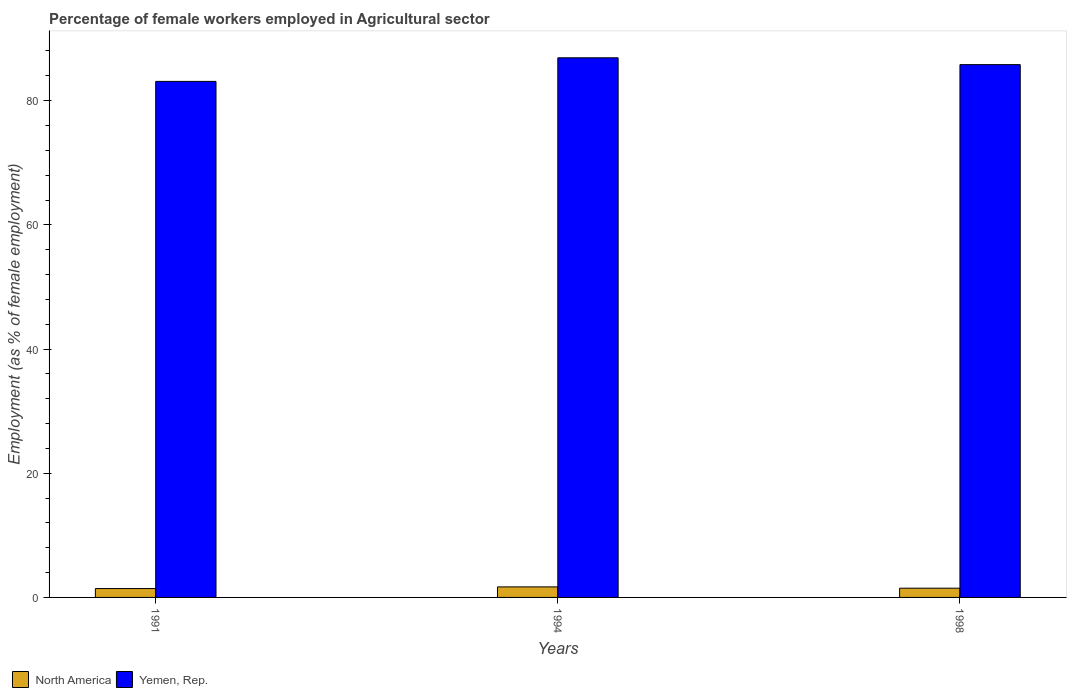How many different coloured bars are there?
Give a very brief answer. 2. Are the number of bars on each tick of the X-axis equal?
Your answer should be very brief. Yes. How many bars are there on the 2nd tick from the right?
Offer a terse response. 2. In how many cases, is the number of bars for a given year not equal to the number of legend labels?
Make the answer very short. 0. What is the percentage of females employed in Agricultural sector in North America in 1998?
Your answer should be very brief. 1.49. Across all years, what is the maximum percentage of females employed in Agricultural sector in Yemen, Rep.?
Offer a very short reply. 86.9. Across all years, what is the minimum percentage of females employed in Agricultural sector in Yemen, Rep.?
Offer a very short reply. 83.1. What is the total percentage of females employed in Agricultural sector in North America in the graph?
Give a very brief answer. 4.61. What is the difference between the percentage of females employed in Agricultural sector in Yemen, Rep. in 1991 and that in 1998?
Provide a succinct answer. -2.7. What is the difference between the percentage of females employed in Agricultural sector in North America in 1991 and the percentage of females employed in Agricultural sector in Yemen, Rep. in 1994?
Your answer should be very brief. -85.47. What is the average percentage of females employed in Agricultural sector in Yemen, Rep. per year?
Offer a terse response. 85.27. In the year 1991, what is the difference between the percentage of females employed in Agricultural sector in North America and percentage of females employed in Agricultural sector in Yemen, Rep.?
Provide a succinct answer. -81.67. What is the ratio of the percentage of females employed in Agricultural sector in North America in 1991 to that in 1994?
Keep it short and to the point. 0.84. Is the percentage of females employed in Agricultural sector in North America in 1991 less than that in 1994?
Your answer should be very brief. Yes. What is the difference between the highest and the second highest percentage of females employed in Agricultural sector in Yemen, Rep.?
Offer a very short reply. 1.1. What is the difference between the highest and the lowest percentage of females employed in Agricultural sector in North America?
Ensure brevity in your answer.  0.27. In how many years, is the percentage of females employed in Agricultural sector in North America greater than the average percentage of females employed in Agricultural sector in North America taken over all years?
Ensure brevity in your answer.  1. What does the 2nd bar from the left in 1991 represents?
Provide a succinct answer. Yemen, Rep. What does the 1st bar from the right in 1991 represents?
Give a very brief answer. Yemen, Rep. How many bars are there?
Your response must be concise. 6. Are all the bars in the graph horizontal?
Provide a short and direct response. No. How many years are there in the graph?
Give a very brief answer. 3. What is the difference between two consecutive major ticks on the Y-axis?
Offer a terse response. 20. Does the graph contain grids?
Make the answer very short. No. Where does the legend appear in the graph?
Your response must be concise. Bottom left. What is the title of the graph?
Ensure brevity in your answer.  Percentage of female workers employed in Agricultural sector. What is the label or title of the X-axis?
Keep it short and to the point. Years. What is the label or title of the Y-axis?
Offer a terse response. Employment (as % of female employment). What is the Employment (as % of female employment) in North America in 1991?
Keep it short and to the point. 1.43. What is the Employment (as % of female employment) in Yemen, Rep. in 1991?
Your response must be concise. 83.1. What is the Employment (as % of female employment) of North America in 1994?
Your answer should be very brief. 1.7. What is the Employment (as % of female employment) in Yemen, Rep. in 1994?
Provide a succinct answer. 86.9. What is the Employment (as % of female employment) of North America in 1998?
Offer a very short reply. 1.49. What is the Employment (as % of female employment) in Yemen, Rep. in 1998?
Give a very brief answer. 85.8. Across all years, what is the maximum Employment (as % of female employment) in North America?
Your response must be concise. 1.7. Across all years, what is the maximum Employment (as % of female employment) of Yemen, Rep.?
Your answer should be compact. 86.9. Across all years, what is the minimum Employment (as % of female employment) of North America?
Provide a succinct answer. 1.43. Across all years, what is the minimum Employment (as % of female employment) of Yemen, Rep.?
Make the answer very short. 83.1. What is the total Employment (as % of female employment) in North America in the graph?
Provide a short and direct response. 4.61. What is the total Employment (as % of female employment) of Yemen, Rep. in the graph?
Make the answer very short. 255.8. What is the difference between the Employment (as % of female employment) of North America in 1991 and that in 1994?
Your answer should be compact. -0.27. What is the difference between the Employment (as % of female employment) of North America in 1991 and that in 1998?
Provide a succinct answer. -0.06. What is the difference between the Employment (as % of female employment) of North America in 1994 and that in 1998?
Your answer should be compact. 0.21. What is the difference between the Employment (as % of female employment) in Yemen, Rep. in 1994 and that in 1998?
Offer a terse response. 1.1. What is the difference between the Employment (as % of female employment) of North America in 1991 and the Employment (as % of female employment) of Yemen, Rep. in 1994?
Ensure brevity in your answer.  -85.47. What is the difference between the Employment (as % of female employment) in North America in 1991 and the Employment (as % of female employment) in Yemen, Rep. in 1998?
Your response must be concise. -84.37. What is the difference between the Employment (as % of female employment) in North America in 1994 and the Employment (as % of female employment) in Yemen, Rep. in 1998?
Your answer should be compact. -84.1. What is the average Employment (as % of female employment) in North America per year?
Provide a succinct answer. 1.54. What is the average Employment (as % of female employment) of Yemen, Rep. per year?
Your answer should be very brief. 85.27. In the year 1991, what is the difference between the Employment (as % of female employment) in North America and Employment (as % of female employment) in Yemen, Rep.?
Ensure brevity in your answer.  -81.67. In the year 1994, what is the difference between the Employment (as % of female employment) of North America and Employment (as % of female employment) of Yemen, Rep.?
Your response must be concise. -85.2. In the year 1998, what is the difference between the Employment (as % of female employment) in North America and Employment (as % of female employment) in Yemen, Rep.?
Your answer should be very brief. -84.31. What is the ratio of the Employment (as % of female employment) of North America in 1991 to that in 1994?
Ensure brevity in your answer.  0.84. What is the ratio of the Employment (as % of female employment) of Yemen, Rep. in 1991 to that in 1994?
Provide a short and direct response. 0.96. What is the ratio of the Employment (as % of female employment) in North America in 1991 to that in 1998?
Give a very brief answer. 0.96. What is the ratio of the Employment (as % of female employment) in Yemen, Rep. in 1991 to that in 1998?
Provide a short and direct response. 0.97. What is the ratio of the Employment (as % of female employment) in North America in 1994 to that in 1998?
Make the answer very short. 1.14. What is the ratio of the Employment (as % of female employment) in Yemen, Rep. in 1994 to that in 1998?
Offer a terse response. 1.01. What is the difference between the highest and the second highest Employment (as % of female employment) in North America?
Provide a succinct answer. 0.21. What is the difference between the highest and the second highest Employment (as % of female employment) in Yemen, Rep.?
Make the answer very short. 1.1. What is the difference between the highest and the lowest Employment (as % of female employment) of North America?
Your answer should be very brief. 0.27. 